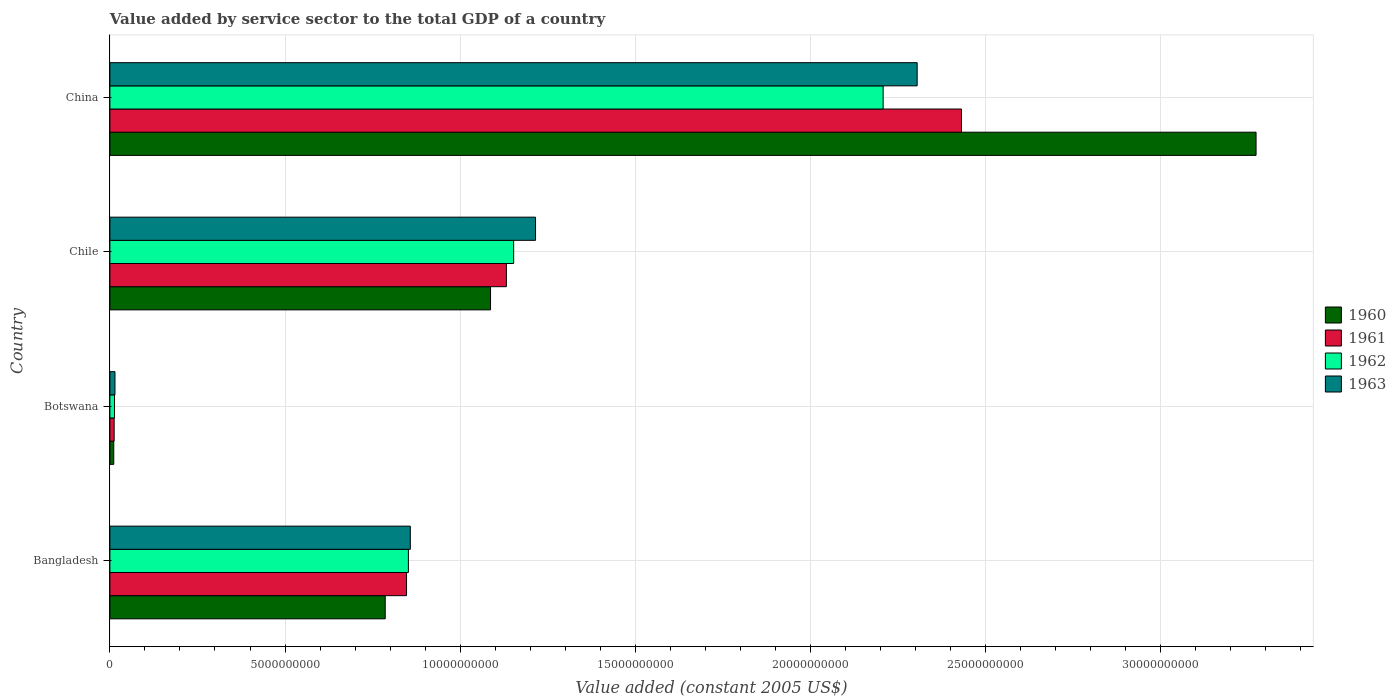How many groups of bars are there?
Your answer should be very brief. 4. Are the number of bars on each tick of the Y-axis equal?
Offer a terse response. Yes. How many bars are there on the 4th tick from the top?
Give a very brief answer. 4. How many bars are there on the 4th tick from the bottom?
Your response must be concise. 4. What is the value added by service sector in 1963 in Botswana?
Ensure brevity in your answer.  1.45e+08. Across all countries, what is the maximum value added by service sector in 1961?
Your answer should be compact. 2.43e+1. Across all countries, what is the minimum value added by service sector in 1962?
Make the answer very short. 1.32e+08. In which country was the value added by service sector in 1963 minimum?
Your answer should be very brief. Botswana. What is the total value added by service sector in 1962 in the graph?
Give a very brief answer. 4.23e+1. What is the difference between the value added by service sector in 1961 in Bangladesh and that in China?
Your response must be concise. -1.58e+1. What is the difference between the value added by service sector in 1962 in Bangladesh and the value added by service sector in 1963 in China?
Your response must be concise. -1.45e+1. What is the average value added by service sector in 1961 per country?
Your answer should be compact. 1.11e+1. What is the difference between the value added by service sector in 1961 and value added by service sector in 1962 in China?
Provide a succinct answer. 2.24e+09. What is the ratio of the value added by service sector in 1962 in Bangladesh to that in Chile?
Your answer should be compact. 0.74. Is the value added by service sector in 1960 in Botswana less than that in Chile?
Keep it short and to the point. Yes. Is the difference between the value added by service sector in 1961 in Bangladesh and China greater than the difference between the value added by service sector in 1962 in Bangladesh and China?
Your answer should be compact. No. What is the difference between the highest and the second highest value added by service sector in 1963?
Provide a succinct answer. 1.09e+1. What is the difference between the highest and the lowest value added by service sector in 1963?
Offer a very short reply. 2.29e+1. Is it the case that in every country, the sum of the value added by service sector in 1961 and value added by service sector in 1962 is greater than the sum of value added by service sector in 1963 and value added by service sector in 1960?
Provide a succinct answer. No. What does the 3rd bar from the top in Chile represents?
Your response must be concise. 1961. What is the difference between two consecutive major ticks on the X-axis?
Keep it short and to the point. 5.00e+09. Does the graph contain grids?
Provide a succinct answer. Yes. Where does the legend appear in the graph?
Keep it short and to the point. Center right. How many legend labels are there?
Provide a succinct answer. 4. How are the legend labels stacked?
Give a very brief answer. Vertical. What is the title of the graph?
Ensure brevity in your answer.  Value added by service sector to the total GDP of a country. Does "1989" appear as one of the legend labels in the graph?
Ensure brevity in your answer.  No. What is the label or title of the X-axis?
Provide a succinct answer. Value added (constant 2005 US$). What is the Value added (constant 2005 US$) of 1960 in Bangladesh?
Provide a succinct answer. 7.86e+09. What is the Value added (constant 2005 US$) of 1961 in Bangladesh?
Your answer should be very brief. 8.47e+09. What is the Value added (constant 2005 US$) in 1962 in Bangladesh?
Offer a terse response. 8.52e+09. What is the Value added (constant 2005 US$) in 1963 in Bangladesh?
Provide a succinct answer. 8.58e+09. What is the Value added (constant 2005 US$) in 1960 in Botswana?
Give a very brief answer. 1.11e+08. What is the Value added (constant 2005 US$) of 1961 in Botswana?
Give a very brief answer. 1.22e+08. What is the Value added (constant 2005 US$) of 1962 in Botswana?
Provide a succinct answer. 1.32e+08. What is the Value added (constant 2005 US$) in 1963 in Botswana?
Your answer should be compact. 1.45e+08. What is the Value added (constant 2005 US$) in 1960 in Chile?
Ensure brevity in your answer.  1.09e+1. What is the Value added (constant 2005 US$) in 1961 in Chile?
Provide a succinct answer. 1.13e+1. What is the Value added (constant 2005 US$) of 1962 in Chile?
Make the answer very short. 1.15e+1. What is the Value added (constant 2005 US$) of 1963 in Chile?
Provide a succinct answer. 1.22e+1. What is the Value added (constant 2005 US$) of 1960 in China?
Your response must be concise. 3.27e+1. What is the Value added (constant 2005 US$) in 1961 in China?
Offer a terse response. 2.43e+1. What is the Value added (constant 2005 US$) of 1962 in China?
Offer a terse response. 2.21e+1. What is the Value added (constant 2005 US$) in 1963 in China?
Offer a very short reply. 2.30e+1. Across all countries, what is the maximum Value added (constant 2005 US$) in 1960?
Your answer should be very brief. 3.27e+1. Across all countries, what is the maximum Value added (constant 2005 US$) in 1961?
Make the answer very short. 2.43e+1. Across all countries, what is the maximum Value added (constant 2005 US$) in 1962?
Make the answer very short. 2.21e+1. Across all countries, what is the maximum Value added (constant 2005 US$) in 1963?
Make the answer very short. 2.30e+1. Across all countries, what is the minimum Value added (constant 2005 US$) in 1960?
Your answer should be compact. 1.11e+08. Across all countries, what is the minimum Value added (constant 2005 US$) in 1961?
Keep it short and to the point. 1.22e+08. Across all countries, what is the minimum Value added (constant 2005 US$) in 1962?
Offer a terse response. 1.32e+08. Across all countries, what is the minimum Value added (constant 2005 US$) in 1963?
Make the answer very short. 1.45e+08. What is the total Value added (constant 2005 US$) in 1960 in the graph?
Offer a terse response. 5.16e+1. What is the total Value added (constant 2005 US$) of 1961 in the graph?
Give a very brief answer. 4.42e+1. What is the total Value added (constant 2005 US$) in 1962 in the graph?
Your answer should be very brief. 4.23e+1. What is the total Value added (constant 2005 US$) of 1963 in the graph?
Provide a short and direct response. 4.39e+1. What is the difference between the Value added (constant 2005 US$) of 1960 in Bangladesh and that in Botswana?
Provide a short and direct response. 7.75e+09. What is the difference between the Value added (constant 2005 US$) in 1961 in Bangladesh and that in Botswana?
Give a very brief answer. 8.35e+09. What is the difference between the Value added (constant 2005 US$) of 1962 in Bangladesh and that in Botswana?
Offer a very short reply. 8.39e+09. What is the difference between the Value added (constant 2005 US$) in 1963 in Bangladesh and that in Botswana?
Make the answer very short. 8.43e+09. What is the difference between the Value added (constant 2005 US$) in 1960 in Bangladesh and that in Chile?
Offer a very short reply. -3.01e+09. What is the difference between the Value added (constant 2005 US$) of 1961 in Bangladesh and that in Chile?
Give a very brief answer. -2.85e+09. What is the difference between the Value added (constant 2005 US$) in 1962 in Bangladesh and that in Chile?
Offer a terse response. -3.00e+09. What is the difference between the Value added (constant 2005 US$) in 1963 in Bangladesh and that in Chile?
Provide a short and direct response. -3.58e+09. What is the difference between the Value added (constant 2005 US$) in 1960 in Bangladesh and that in China?
Your answer should be compact. -2.49e+1. What is the difference between the Value added (constant 2005 US$) in 1961 in Bangladesh and that in China?
Offer a terse response. -1.58e+1. What is the difference between the Value added (constant 2005 US$) in 1962 in Bangladesh and that in China?
Give a very brief answer. -1.36e+1. What is the difference between the Value added (constant 2005 US$) of 1963 in Bangladesh and that in China?
Provide a short and direct response. -1.45e+1. What is the difference between the Value added (constant 2005 US$) of 1960 in Botswana and that in Chile?
Provide a short and direct response. -1.08e+1. What is the difference between the Value added (constant 2005 US$) of 1961 in Botswana and that in Chile?
Give a very brief answer. -1.12e+1. What is the difference between the Value added (constant 2005 US$) in 1962 in Botswana and that in Chile?
Provide a succinct answer. -1.14e+1. What is the difference between the Value added (constant 2005 US$) in 1963 in Botswana and that in Chile?
Your answer should be compact. -1.20e+1. What is the difference between the Value added (constant 2005 US$) of 1960 in Botswana and that in China?
Your answer should be compact. -3.26e+1. What is the difference between the Value added (constant 2005 US$) in 1961 in Botswana and that in China?
Offer a very short reply. -2.42e+1. What is the difference between the Value added (constant 2005 US$) of 1962 in Botswana and that in China?
Ensure brevity in your answer.  -2.19e+1. What is the difference between the Value added (constant 2005 US$) of 1963 in Botswana and that in China?
Give a very brief answer. -2.29e+1. What is the difference between the Value added (constant 2005 US$) of 1960 in Chile and that in China?
Your answer should be very brief. -2.19e+1. What is the difference between the Value added (constant 2005 US$) of 1961 in Chile and that in China?
Provide a short and direct response. -1.30e+1. What is the difference between the Value added (constant 2005 US$) in 1962 in Chile and that in China?
Provide a short and direct response. -1.05e+1. What is the difference between the Value added (constant 2005 US$) in 1963 in Chile and that in China?
Provide a succinct answer. -1.09e+1. What is the difference between the Value added (constant 2005 US$) of 1960 in Bangladesh and the Value added (constant 2005 US$) of 1961 in Botswana?
Your answer should be compact. 7.74e+09. What is the difference between the Value added (constant 2005 US$) in 1960 in Bangladesh and the Value added (constant 2005 US$) in 1962 in Botswana?
Your answer should be compact. 7.73e+09. What is the difference between the Value added (constant 2005 US$) in 1960 in Bangladesh and the Value added (constant 2005 US$) in 1963 in Botswana?
Your answer should be compact. 7.72e+09. What is the difference between the Value added (constant 2005 US$) of 1961 in Bangladesh and the Value added (constant 2005 US$) of 1962 in Botswana?
Your answer should be compact. 8.34e+09. What is the difference between the Value added (constant 2005 US$) of 1961 in Bangladesh and the Value added (constant 2005 US$) of 1963 in Botswana?
Your answer should be very brief. 8.32e+09. What is the difference between the Value added (constant 2005 US$) of 1962 in Bangladesh and the Value added (constant 2005 US$) of 1963 in Botswana?
Offer a terse response. 8.38e+09. What is the difference between the Value added (constant 2005 US$) in 1960 in Bangladesh and the Value added (constant 2005 US$) in 1961 in Chile?
Give a very brief answer. -3.46e+09. What is the difference between the Value added (constant 2005 US$) of 1960 in Bangladesh and the Value added (constant 2005 US$) of 1962 in Chile?
Provide a short and direct response. -3.67e+09. What is the difference between the Value added (constant 2005 US$) in 1960 in Bangladesh and the Value added (constant 2005 US$) in 1963 in Chile?
Give a very brief answer. -4.29e+09. What is the difference between the Value added (constant 2005 US$) in 1961 in Bangladesh and the Value added (constant 2005 US$) in 1962 in Chile?
Offer a terse response. -3.06e+09. What is the difference between the Value added (constant 2005 US$) in 1961 in Bangladesh and the Value added (constant 2005 US$) in 1963 in Chile?
Your answer should be very brief. -3.68e+09. What is the difference between the Value added (constant 2005 US$) of 1962 in Bangladesh and the Value added (constant 2005 US$) of 1963 in Chile?
Your answer should be very brief. -3.63e+09. What is the difference between the Value added (constant 2005 US$) in 1960 in Bangladesh and the Value added (constant 2005 US$) in 1961 in China?
Keep it short and to the point. -1.65e+1. What is the difference between the Value added (constant 2005 US$) in 1960 in Bangladesh and the Value added (constant 2005 US$) in 1962 in China?
Keep it short and to the point. -1.42e+1. What is the difference between the Value added (constant 2005 US$) of 1960 in Bangladesh and the Value added (constant 2005 US$) of 1963 in China?
Offer a terse response. -1.52e+1. What is the difference between the Value added (constant 2005 US$) of 1961 in Bangladesh and the Value added (constant 2005 US$) of 1962 in China?
Make the answer very short. -1.36e+1. What is the difference between the Value added (constant 2005 US$) in 1961 in Bangladesh and the Value added (constant 2005 US$) in 1963 in China?
Keep it short and to the point. -1.46e+1. What is the difference between the Value added (constant 2005 US$) of 1962 in Bangladesh and the Value added (constant 2005 US$) of 1963 in China?
Provide a short and direct response. -1.45e+1. What is the difference between the Value added (constant 2005 US$) in 1960 in Botswana and the Value added (constant 2005 US$) in 1961 in Chile?
Provide a succinct answer. -1.12e+1. What is the difference between the Value added (constant 2005 US$) of 1960 in Botswana and the Value added (constant 2005 US$) of 1962 in Chile?
Offer a terse response. -1.14e+1. What is the difference between the Value added (constant 2005 US$) of 1960 in Botswana and the Value added (constant 2005 US$) of 1963 in Chile?
Ensure brevity in your answer.  -1.20e+1. What is the difference between the Value added (constant 2005 US$) in 1961 in Botswana and the Value added (constant 2005 US$) in 1962 in Chile?
Provide a short and direct response. -1.14e+1. What is the difference between the Value added (constant 2005 US$) of 1961 in Botswana and the Value added (constant 2005 US$) of 1963 in Chile?
Your answer should be compact. -1.20e+1. What is the difference between the Value added (constant 2005 US$) in 1962 in Botswana and the Value added (constant 2005 US$) in 1963 in Chile?
Your answer should be very brief. -1.20e+1. What is the difference between the Value added (constant 2005 US$) in 1960 in Botswana and the Value added (constant 2005 US$) in 1961 in China?
Make the answer very short. -2.42e+1. What is the difference between the Value added (constant 2005 US$) of 1960 in Botswana and the Value added (constant 2005 US$) of 1962 in China?
Make the answer very short. -2.20e+1. What is the difference between the Value added (constant 2005 US$) of 1960 in Botswana and the Value added (constant 2005 US$) of 1963 in China?
Give a very brief answer. -2.29e+1. What is the difference between the Value added (constant 2005 US$) in 1961 in Botswana and the Value added (constant 2005 US$) in 1962 in China?
Ensure brevity in your answer.  -2.20e+1. What is the difference between the Value added (constant 2005 US$) in 1961 in Botswana and the Value added (constant 2005 US$) in 1963 in China?
Give a very brief answer. -2.29e+1. What is the difference between the Value added (constant 2005 US$) in 1962 in Botswana and the Value added (constant 2005 US$) in 1963 in China?
Ensure brevity in your answer.  -2.29e+1. What is the difference between the Value added (constant 2005 US$) of 1960 in Chile and the Value added (constant 2005 US$) of 1961 in China?
Make the answer very short. -1.34e+1. What is the difference between the Value added (constant 2005 US$) of 1960 in Chile and the Value added (constant 2005 US$) of 1962 in China?
Give a very brief answer. -1.12e+1. What is the difference between the Value added (constant 2005 US$) in 1960 in Chile and the Value added (constant 2005 US$) in 1963 in China?
Ensure brevity in your answer.  -1.22e+1. What is the difference between the Value added (constant 2005 US$) in 1961 in Chile and the Value added (constant 2005 US$) in 1962 in China?
Make the answer very short. -1.08e+1. What is the difference between the Value added (constant 2005 US$) in 1961 in Chile and the Value added (constant 2005 US$) in 1963 in China?
Make the answer very short. -1.17e+1. What is the difference between the Value added (constant 2005 US$) of 1962 in Chile and the Value added (constant 2005 US$) of 1963 in China?
Offer a very short reply. -1.15e+1. What is the average Value added (constant 2005 US$) in 1960 per country?
Keep it short and to the point. 1.29e+1. What is the average Value added (constant 2005 US$) in 1961 per country?
Your response must be concise. 1.11e+1. What is the average Value added (constant 2005 US$) of 1962 per country?
Make the answer very short. 1.06e+1. What is the average Value added (constant 2005 US$) of 1963 per country?
Keep it short and to the point. 1.10e+1. What is the difference between the Value added (constant 2005 US$) of 1960 and Value added (constant 2005 US$) of 1961 in Bangladesh?
Give a very brief answer. -6.09e+08. What is the difference between the Value added (constant 2005 US$) of 1960 and Value added (constant 2005 US$) of 1962 in Bangladesh?
Ensure brevity in your answer.  -6.62e+08. What is the difference between the Value added (constant 2005 US$) in 1960 and Value added (constant 2005 US$) in 1963 in Bangladesh?
Your response must be concise. -7.16e+08. What is the difference between the Value added (constant 2005 US$) in 1961 and Value added (constant 2005 US$) in 1962 in Bangladesh?
Provide a succinct answer. -5.33e+07. What is the difference between the Value added (constant 2005 US$) of 1961 and Value added (constant 2005 US$) of 1963 in Bangladesh?
Ensure brevity in your answer.  -1.08e+08. What is the difference between the Value added (constant 2005 US$) in 1962 and Value added (constant 2005 US$) in 1963 in Bangladesh?
Your response must be concise. -5.45e+07. What is the difference between the Value added (constant 2005 US$) in 1960 and Value added (constant 2005 US$) in 1961 in Botswana?
Provide a short and direct response. -1.12e+07. What is the difference between the Value added (constant 2005 US$) in 1960 and Value added (constant 2005 US$) in 1962 in Botswana?
Your response must be concise. -2.17e+07. What is the difference between the Value added (constant 2005 US$) in 1960 and Value added (constant 2005 US$) in 1963 in Botswana?
Provide a short and direct response. -3.45e+07. What is the difference between the Value added (constant 2005 US$) in 1961 and Value added (constant 2005 US$) in 1962 in Botswana?
Provide a short and direct response. -1.05e+07. What is the difference between the Value added (constant 2005 US$) in 1961 and Value added (constant 2005 US$) in 1963 in Botswana?
Your response must be concise. -2.33e+07. What is the difference between the Value added (constant 2005 US$) in 1962 and Value added (constant 2005 US$) in 1963 in Botswana?
Offer a very short reply. -1.28e+07. What is the difference between the Value added (constant 2005 US$) of 1960 and Value added (constant 2005 US$) of 1961 in Chile?
Make the answer very short. -4.53e+08. What is the difference between the Value added (constant 2005 US$) of 1960 and Value added (constant 2005 US$) of 1962 in Chile?
Your answer should be very brief. -6.60e+08. What is the difference between the Value added (constant 2005 US$) in 1960 and Value added (constant 2005 US$) in 1963 in Chile?
Offer a terse response. -1.29e+09. What is the difference between the Value added (constant 2005 US$) of 1961 and Value added (constant 2005 US$) of 1962 in Chile?
Keep it short and to the point. -2.07e+08. What is the difference between the Value added (constant 2005 US$) in 1961 and Value added (constant 2005 US$) in 1963 in Chile?
Ensure brevity in your answer.  -8.32e+08. What is the difference between the Value added (constant 2005 US$) of 1962 and Value added (constant 2005 US$) of 1963 in Chile?
Give a very brief answer. -6.25e+08. What is the difference between the Value added (constant 2005 US$) of 1960 and Value added (constant 2005 US$) of 1961 in China?
Make the answer very short. 8.41e+09. What is the difference between the Value added (constant 2005 US$) in 1960 and Value added (constant 2005 US$) in 1962 in China?
Make the answer very short. 1.06e+1. What is the difference between the Value added (constant 2005 US$) in 1960 and Value added (constant 2005 US$) in 1963 in China?
Provide a short and direct response. 9.68e+09. What is the difference between the Value added (constant 2005 US$) in 1961 and Value added (constant 2005 US$) in 1962 in China?
Your answer should be compact. 2.24e+09. What is the difference between the Value added (constant 2005 US$) of 1961 and Value added (constant 2005 US$) of 1963 in China?
Your answer should be very brief. 1.27e+09. What is the difference between the Value added (constant 2005 US$) of 1962 and Value added (constant 2005 US$) of 1963 in China?
Give a very brief answer. -9.71e+08. What is the ratio of the Value added (constant 2005 US$) of 1960 in Bangladesh to that in Botswana?
Your answer should be compact. 71.09. What is the ratio of the Value added (constant 2005 US$) of 1961 in Bangladesh to that in Botswana?
Give a very brief answer. 69.55. What is the ratio of the Value added (constant 2005 US$) of 1962 in Bangladesh to that in Botswana?
Keep it short and to the point. 64.43. What is the ratio of the Value added (constant 2005 US$) in 1963 in Bangladesh to that in Botswana?
Provide a succinct answer. 59.12. What is the ratio of the Value added (constant 2005 US$) in 1960 in Bangladesh to that in Chile?
Offer a very short reply. 0.72. What is the ratio of the Value added (constant 2005 US$) in 1961 in Bangladesh to that in Chile?
Give a very brief answer. 0.75. What is the ratio of the Value added (constant 2005 US$) in 1962 in Bangladesh to that in Chile?
Ensure brevity in your answer.  0.74. What is the ratio of the Value added (constant 2005 US$) in 1963 in Bangladesh to that in Chile?
Offer a terse response. 0.71. What is the ratio of the Value added (constant 2005 US$) of 1960 in Bangladesh to that in China?
Ensure brevity in your answer.  0.24. What is the ratio of the Value added (constant 2005 US$) of 1961 in Bangladesh to that in China?
Offer a terse response. 0.35. What is the ratio of the Value added (constant 2005 US$) of 1962 in Bangladesh to that in China?
Provide a short and direct response. 0.39. What is the ratio of the Value added (constant 2005 US$) of 1963 in Bangladesh to that in China?
Keep it short and to the point. 0.37. What is the ratio of the Value added (constant 2005 US$) of 1960 in Botswana to that in Chile?
Ensure brevity in your answer.  0.01. What is the ratio of the Value added (constant 2005 US$) of 1961 in Botswana to that in Chile?
Give a very brief answer. 0.01. What is the ratio of the Value added (constant 2005 US$) of 1962 in Botswana to that in Chile?
Offer a terse response. 0.01. What is the ratio of the Value added (constant 2005 US$) in 1963 in Botswana to that in Chile?
Provide a short and direct response. 0.01. What is the ratio of the Value added (constant 2005 US$) in 1960 in Botswana to that in China?
Ensure brevity in your answer.  0. What is the ratio of the Value added (constant 2005 US$) in 1961 in Botswana to that in China?
Provide a succinct answer. 0.01. What is the ratio of the Value added (constant 2005 US$) in 1962 in Botswana to that in China?
Your answer should be compact. 0.01. What is the ratio of the Value added (constant 2005 US$) in 1963 in Botswana to that in China?
Your response must be concise. 0.01. What is the ratio of the Value added (constant 2005 US$) of 1960 in Chile to that in China?
Ensure brevity in your answer.  0.33. What is the ratio of the Value added (constant 2005 US$) of 1961 in Chile to that in China?
Your response must be concise. 0.47. What is the ratio of the Value added (constant 2005 US$) of 1962 in Chile to that in China?
Your answer should be compact. 0.52. What is the ratio of the Value added (constant 2005 US$) of 1963 in Chile to that in China?
Provide a succinct answer. 0.53. What is the difference between the highest and the second highest Value added (constant 2005 US$) in 1960?
Your answer should be very brief. 2.19e+1. What is the difference between the highest and the second highest Value added (constant 2005 US$) of 1961?
Offer a very short reply. 1.30e+1. What is the difference between the highest and the second highest Value added (constant 2005 US$) of 1962?
Give a very brief answer. 1.05e+1. What is the difference between the highest and the second highest Value added (constant 2005 US$) in 1963?
Give a very brief answer. 1.09e+1. What is the difference between the highest and the lowest Value added (constant 2005 US$) in 1960?
Offer a terse response. 3.26e+1. What is the difference between the highest and the lowest Value added (constant 2005 US$) in 1961?
Offer a terse response. 2.42e+1. What is the difference between the highest and the lowest Value added (constant 2005 US$) in 1962?
Ensure brevity in your answer.  2.19e+1. What is the difference between the highest and the lowest Value added (constant 2005 US$) in 1963?
Your answer should be compact. 2.29e+1. 